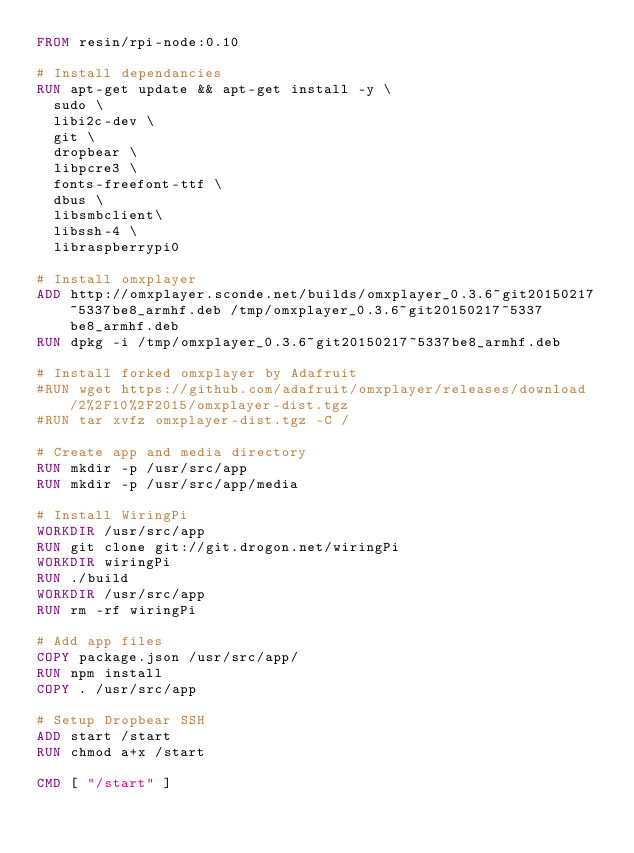Convert code to text. <code><loc_0><loc_0><loc_500><loc_500><_Dockerfile_>FROM resin/rpi-node:0.10

# Install dependancies
RUN apt-get update && apt-get install -y \
  sudo \
  libi2c-dev \
  git \
  dropbear \
  libpcre3 \
  fonts-freefont-ttf \
  dbus \
  libsmbclient\
  libssh-4 \
  libraspberrypi0

# Install omxplayer
ADD http://omxplayer.sconde.net/builds/omxplayer_0.3.6~git20150217~5337be8_armhf.deb /tmp/omxplayer_0.3.6~git20150217~5337be8_armhf.deb
RUN dpkg -i /tmp/omxplayer_0.3.6~git20150217~5337be8_armhf.deb

# Install forked omxplayer by Adafruit
#RUN wget https://github.com/adafruit/omxplayer/releases/download/2%2F10%2F2015/omxplayer-dist.tgz
#RUN tar xvfz omxplayer-dist.tgz -C /

# Create app and media directory
RUN mkdir -p /usr/src/app
RUN mkdir -p /usr/src/app/media

# Install WiringPi
WORKDIR /usr/src/app
RUN git clone git://git.drogon.net/wiringPi
WORKDIR wiringPi
RUN ./build
WORKDIR /usr/src/app
RUN rm -rf wiringPi

# Add app files
COPY package.json /usr/src/app/
RUN npm install
COPY . /usr/src/app

# Setup Dropbear SSH
ADD start /start
RUN chmod a+x /start

CMD [ "/start" ]
</code> 